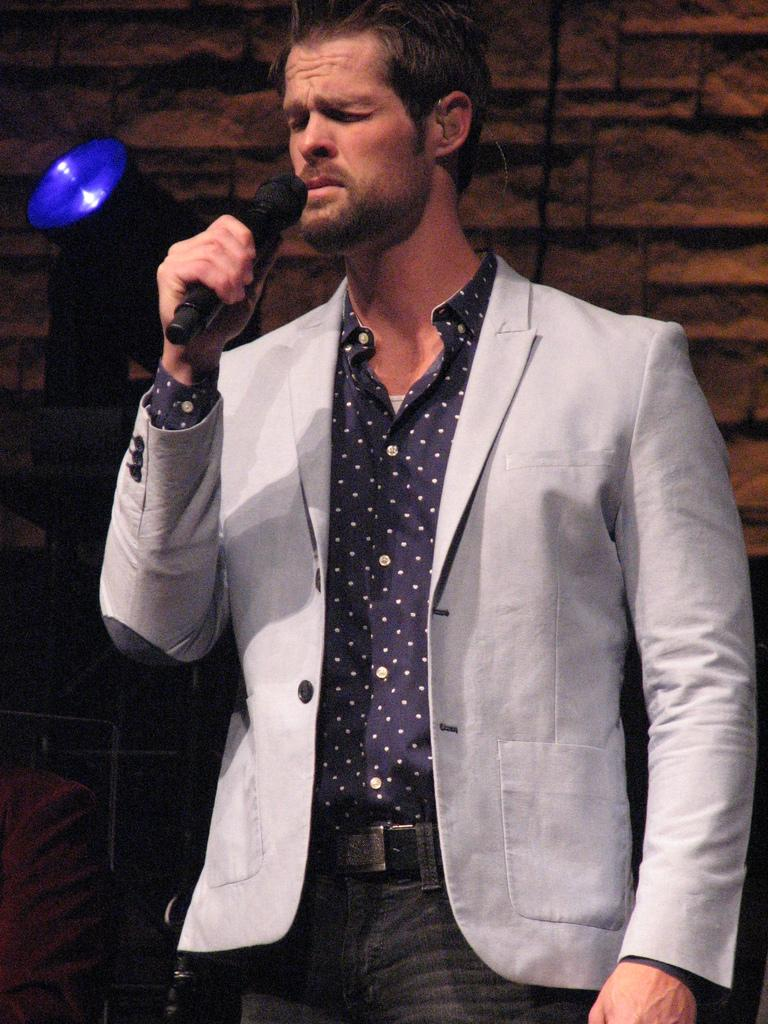What is the appearance of the person in the image? There is a man in the image, and he is wearing a suit. What is the man holding in the image? The man is holding a microphone. What is the man doing with his eyes in the image? The man has his eyes closed. What can be seen in the image that might be used for lighting purposes? There is a focusing light in the image. What type of substance can be seen spilling out of the microphone in the image? There is no substance spilling out of the microphone in the image. 